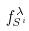<formula> <loc_0><loc_0><loc_500><loc_500>f _ { S ^ { i } } ^ { \lambda }</formula> 